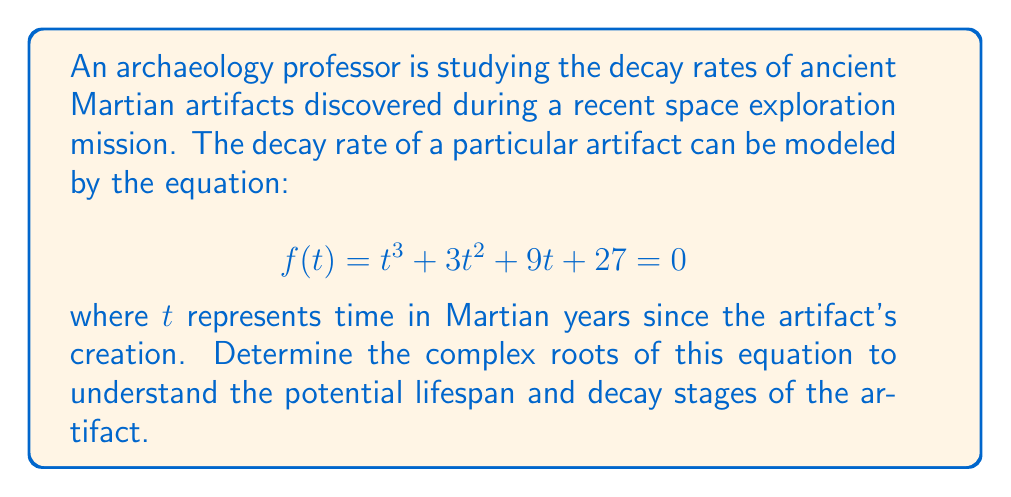Could you help me with this problem? To find the complex roots of the equation $t^3 + 3t^2 + 9t + 27 = 0$, we can follow these steps:

1) First, we recognize this as a cubic equation in the form $at^3 + bt^2 + ct + d = 0$, where $a=1$, $b=3$, $c=9$, and $d=27$.

2) We can use Cardano's formula to solve this cubic equation. Let's start by calculating some intermediate values:

   $p = \frac{3ac-b^2}{3a^2} = \frac{3(1)(9)-3^2}{3(1)^2} = 8$
   
   $q = \frac{2b^3-9abc+27a^2d}{27a^3} = \frac{2(3)^3-9(1)(3)(9)+27(1)^2(27)}{27(1)^3} = 28$

3) Now we calculate the discriminant $\Delta$:

   $\Delta = (\frac{q}{2})^2 + (\frac{p}{3})^3 = (\frac{28}{2})^2 + (\frac{8}{3})^3 = 196 + \frac{512}{27} = 196 + 18.963 = 214.963$

4) Since $\Delta > 0$, the equation has one real root and two complex conjugate roots.

5) We calculate the following:

   $u = \sqrt[3]{-\frac{q}{2} + \sqrt{\Delta}} = \sqrt[3]{-14 + \sqrt{214.963}} \approx 2.769$
   
   $v = \sqrt[3]{-\frac{q}{2} - \sqrt{\Delta}} = \sqrt[3]{-14 - \sqrt{214.963}} \approx -3.769$

6) The roots are given by:

   $t_1 = u + v - \frac{b}{3a} = 2.769 + (-3.769) - \frac{3}{3} = -2$

   $t_2 = -\frac{1}{2}(u+v) - \frac{b}{3a} + i\frac{\sqrt{3}}{2}(u-v)$
   
   $t_3 = -\frac{1}{2}(u+v) - \frac{b}{3a} - i\frac{\sqrt{3}}{2}(u-v)$

7) Calculating $t_2$ and $t_3$:

   $t_2 = -\frac{1}{2}(2.769-3.769) - 1 + i\frac{\sqrt{3}}{2}(2.769+3.769) = 0.5 + 5.65i$
   
   $t_3 = -\frac{1}{2}(2.769-3.769) - 1 - i\frac{\sqrt{3}}{2}(2.769+3.769) = 0.5 - 5.65i$
Answer: The complex roots of the equation are:

$t_1 = -2$
$t_2 = 0.5 + 5.65i$
$t_3 = 0.5 - 5.65i$

where $i$ is the imaginary unit. 